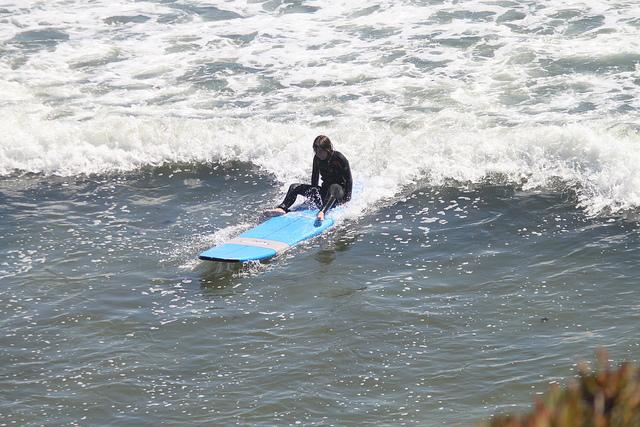Is the surfer waiting for a wave?
Concise answer only. Yes. Is the man in a standing position?
Short answer required. No. Is the surfer sitting down?
Write a very short answer. Yes. How many surfers are there?
Quick response, please. 1. What is the surfer wearing?
Short answer required. Wetsuit. 